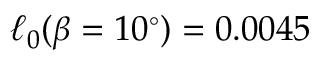Convert formula to latex. <formula><loc_0><loc_0><loc_500><loc_500>\ell _ { 0 } ( \beta = 1 0 ^ { \circ } ) = 0 . 0 0 4 5</formula> 